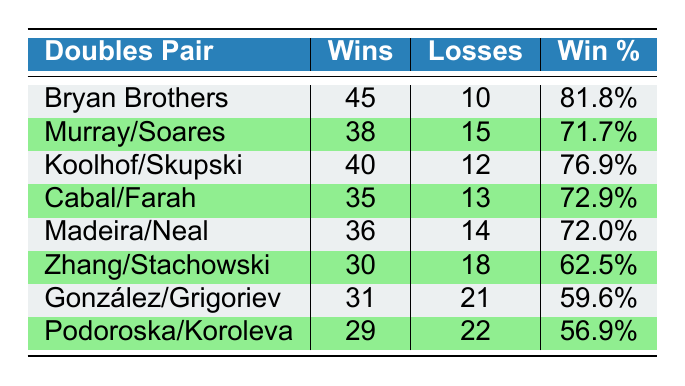How many wins did the Bryan Brothers have? The table lists the wins for the Bryan Brothers as 45.
Answer: 45 Which pair has the highest win percentage? The win percentages are as follows: Bryan Brothers (81.8%), Murray/Soares (71.7%), Koolhof/Skupski (76.9%), Cabal/Farah (72.9%), Madeira/Neal (72.0%), Zhang/Stachowski (62.5%), González/Grigoriev (59.6%), and Podoroska/Koroleva (56.9%). The highest value is 81.8%, held by the Bryan Brothers.
Answer: Bryan Brothers What is the total number of losses for all the pairs combined? Adding the losses from each pair: 10 (Bryan Brothers) + 15 (Murray/Soares) + 12 (Koolhof/Skupski) + 13 (Cabal/Farah) + 14 (Madeira/Neal) + 18 (Zhang/Stachowski) + 21 (González/Grigoriev) + 22 (Podoroska/Koroleva) gives a total of 10 + 15 + 12 + 13 + 14 + 18 + 21 + 22 =  115.
Answer: 115 Is it true that Zhang/Stachowski has more wins than González/Grigoriev? Zhang/Stachowski has 30 wins, while González/Grigoriev has 31 wins. Therefore, it is false that Zhang/Stachowski has more wins.
Answer: No What is the average number of wins for the pairs listed? The total wins are 45 + 38 + 40 + 35 + 36 + 30 + 31 + 29 = 314. There are 8 pairs, so the average is 314 / 8 = 39.25.
Answer: 39.25 Which pairs have a win percentage greater than 70%? The pairs with win percentages greater than 70% are Bryan Brothers (81.8%), Koolhof/Skupski (76.9%), Murray/Soares (71.7%), and Cabal/Farah (72.9%). Count them: there are 4 such pairs.
Answer: 4 What is the difference in wins between the pair with the most wins and the pair with the least wins? The pair with the most wins is the Bryan Brothers (45 wins), and the pair with the least wins is Podoroska/Koroleva (29 wins). The difference is 45 - 29 = 16.
Answer: 16 